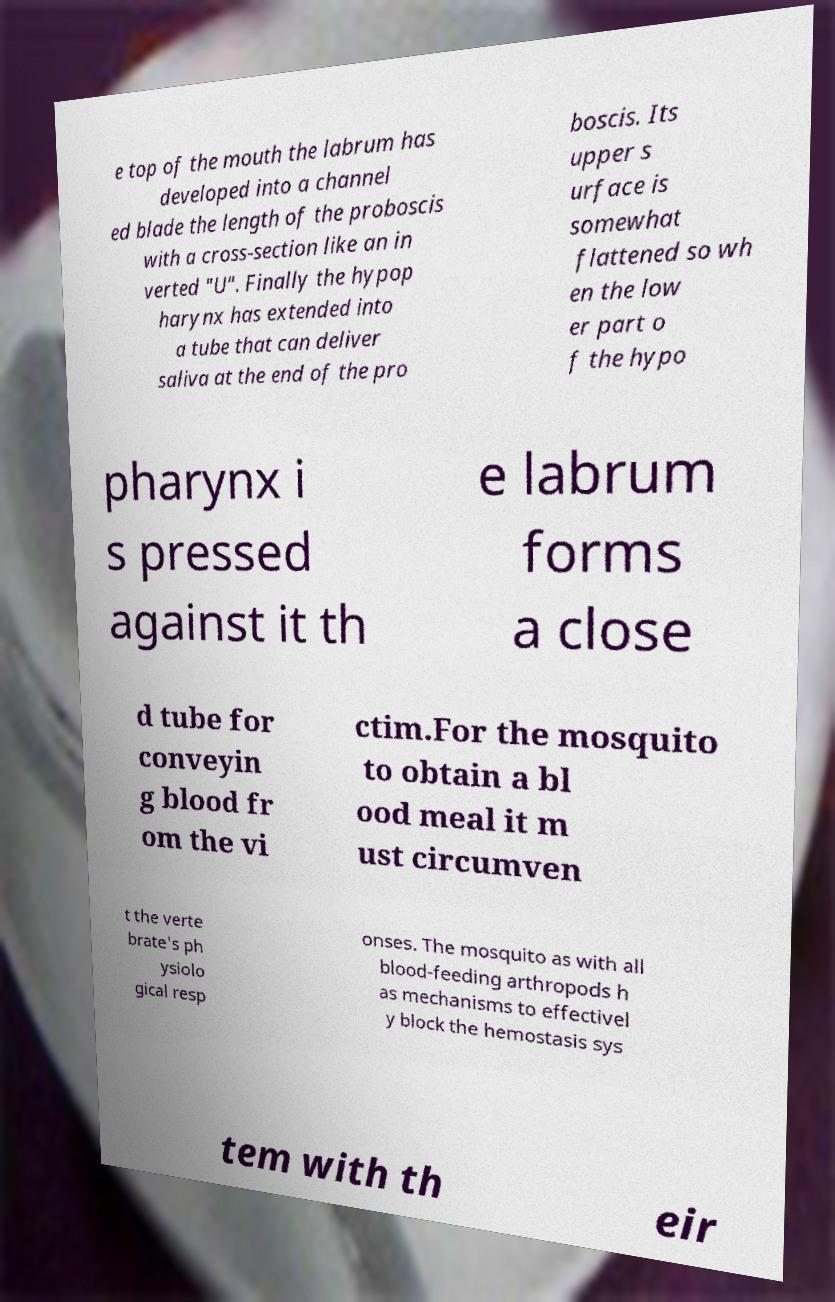Please identify and transcribe the text found in this image. e top of the mouth the labrum has developed into a channel ed blade the length of the proboscis with a cross-section like an in verted "U". Finally the hypop harynx has extended into a tube that can deliver saliva at the end of the pro boscis. Its upper s urface is somewhat flattened so wh en the low er part o f the hypo pharynx i s pressed against it th e labrum forms a close d tube for conveyin g blood fr om the vi ctim.For the mosquito to obtain a bl ood meal it m ust circumven t the verte brate's ph ysiolo gical resp onses. The mosquito as with all blood-feeding arthropods h as mechanisms to effectivel y block the hemostasis sys tem with th eir 